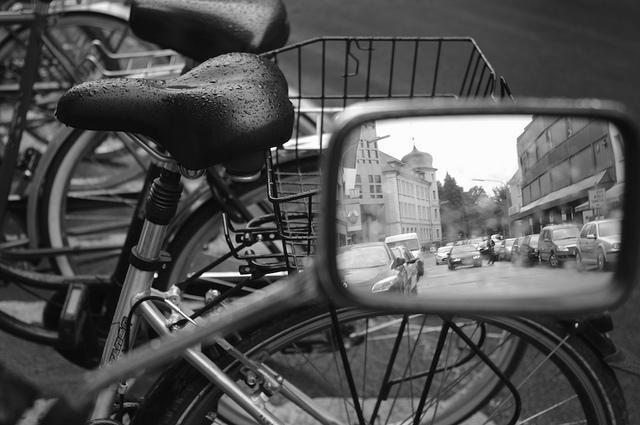How many cars are there?
Give a very brief answer. 2. How many bicycles are visible?
Give a very brief answer. 5. 